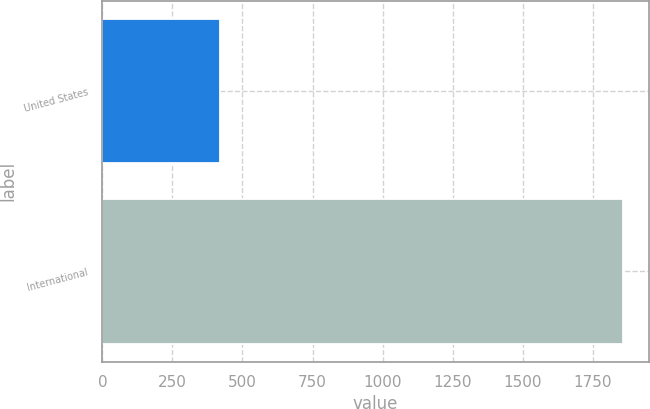Convert chart. <chart><loc_0><loc_0><loc_500><loc_500><bar_chart><fcel>United States<fcel>International<nl><fcel>418<fcel>1858<nl></chart> 